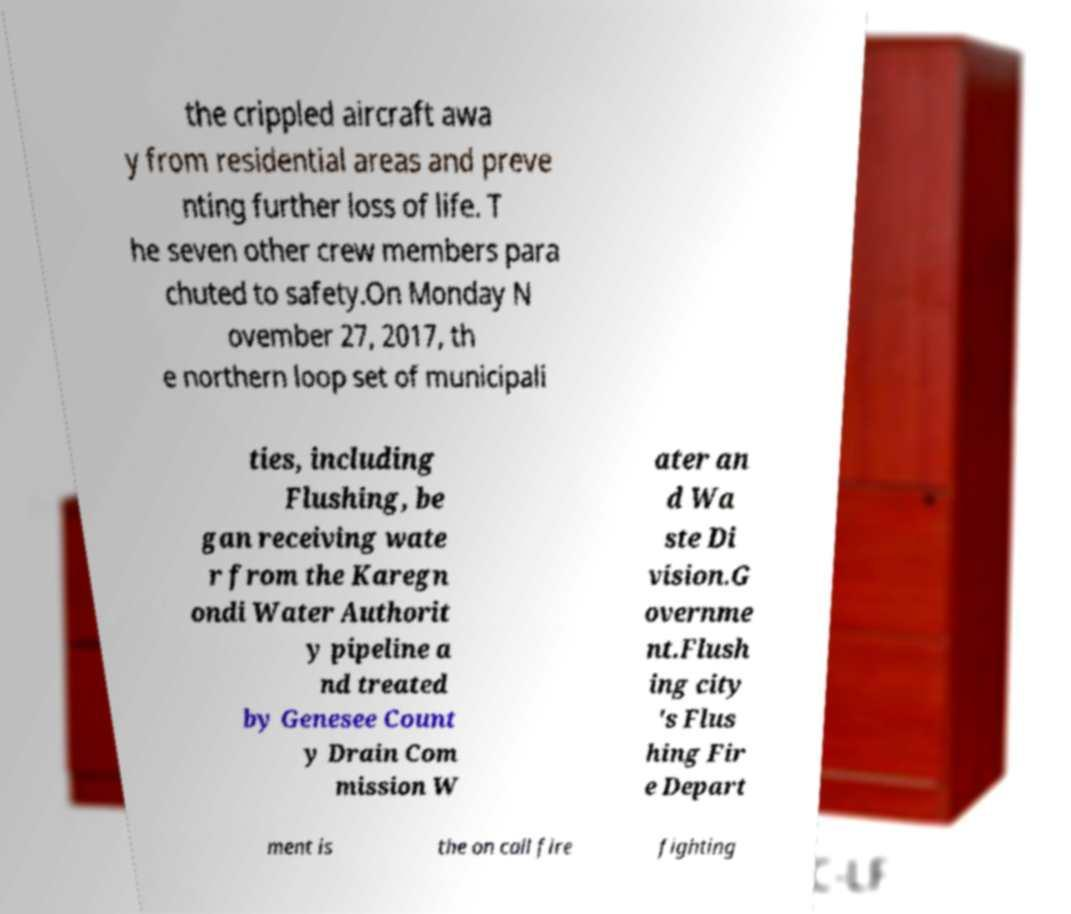Could you assist in decoding the text presented in this image and type it out clearly? the crippled aircraft awa y from residential areas and preve nting further loss of life. T he seven other crew members para chuted to safety.On Monday N ovember 27, 2017, th e northern loop set of municipali ties, including Flushing, be gan receiving wate r from the Karegn ondi Water Authorit y pipeline a nd treated by Genesee Count y Drain Com mission W ater an d Wa ste Di vision.G overnme nt.Flush ing city 's Flus hing Fir e Depart ment is the on call fire fighting 